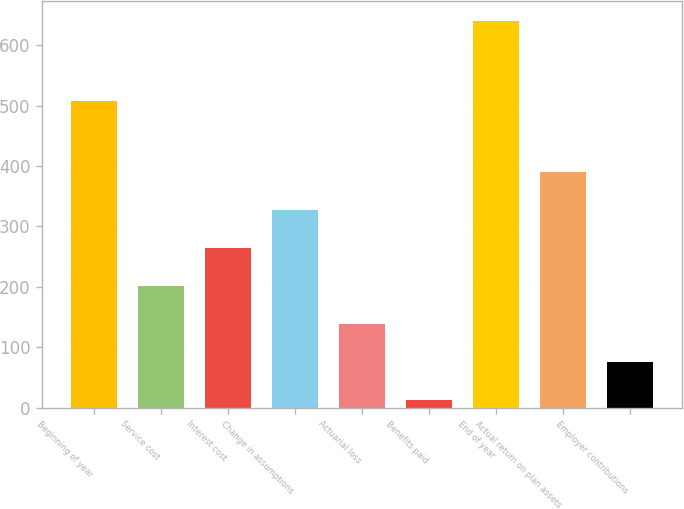Convert chart to OTSL. <chart><loc_0><loc_0><loc_500><loc_500><bar_chart><fcel>Beginning of year<fcel>Service cost<fcel>Interest cost<fcel>Change in assumptions<fcel>Actuarial loss<fcel>Benefits paid<fcel>End of year<fcel>Actual return on plan assets<fcel>Employer contributions<nl><fcel>507.2<fcel>201.38<fcel>264.14<fcel>326.9<fcel>138.62<fcel>13.1<fcel>640.7<fcel>389.66<fcel>75.86<nl></chart> 